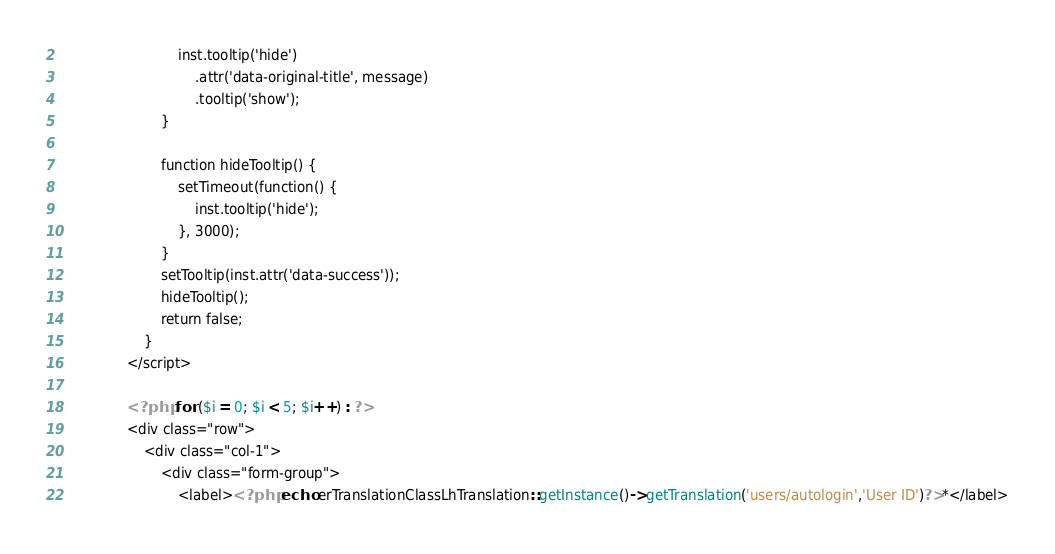Convert code to text. <code><loc_0><loc_0><loc_500><loc_500><_PHP_>                            inst.tooltip('hide')
                                .attr('data-original-title', message)
                                .tooltip('show');
                        }

                        function hideTooltip() {
                            setTimeout(function() {
                                inst.tooltip('hide');
                            }, 3000);
                        }
                        setTooltip(inst.attr('data-success'));
                        hideTooltip();
                        return false;
                    }
                </script>

                <?php for ($i = 0; $i < 5; $i++) : ?>
                <div class="row">
                    <div class="col-1">
                        <div class="form-group">
                            <label><?php echo erTranslationClassLhTranslation::getInstance()->getTranslation('users/autologin','User ID')?>*</label></code> 